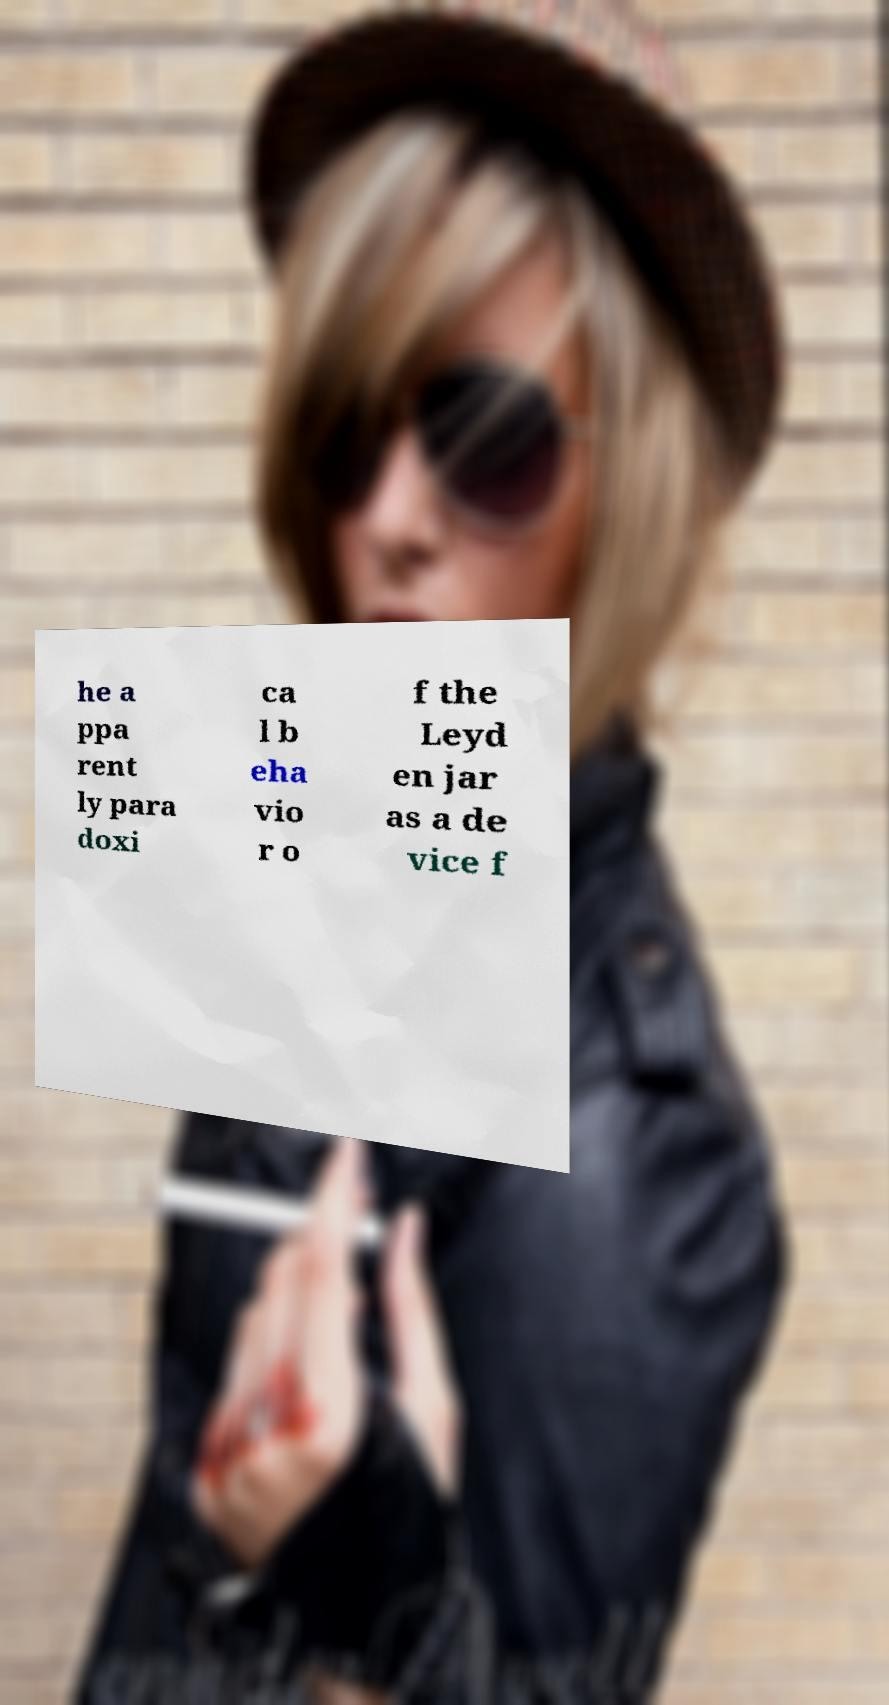There's text embedded in this image that I need extracted. Can you transcribe it verbatim? he a ppa rent ly para doxi ca l b eha vio r o f the Leyd en jar as a de vice f 